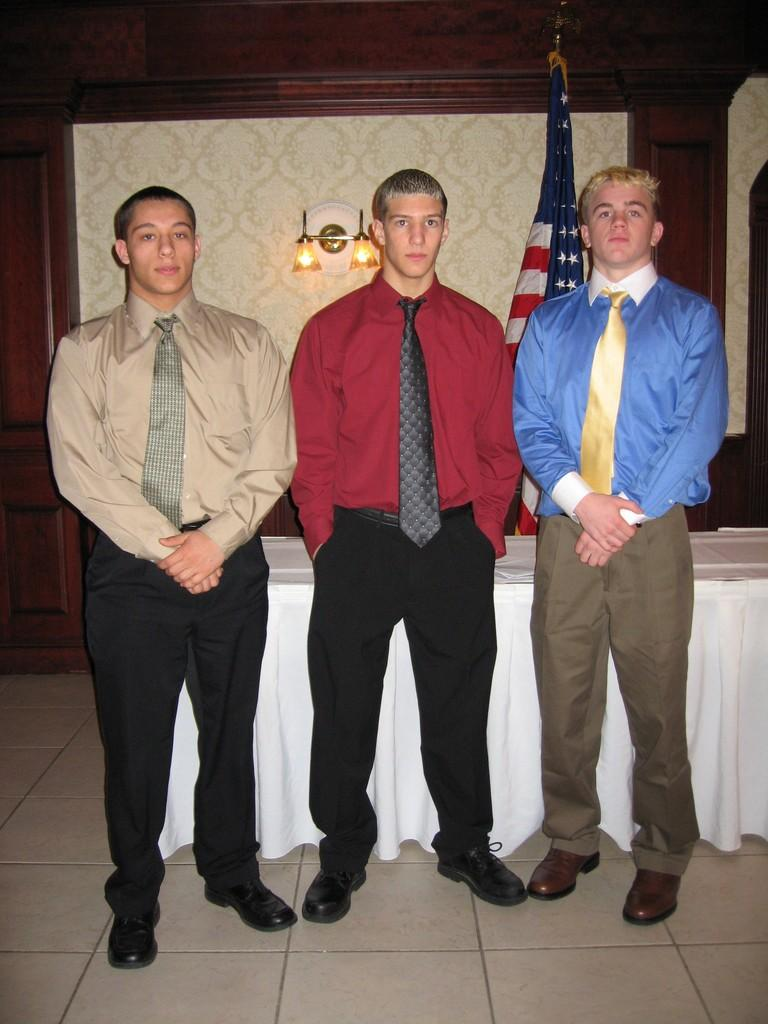What can be seen in the image regarding people? There are persons standing in the image. What is visible beneath the persons' feet? The floor is visible in the image. What is present on the table in the image? There is a table covered with cloth in the image. What is the symbolic object in the image? There is a flag in the image. What type of lighting is present in the image? Electric lights are attached to the walls in the image. What type of texture can be seen on the rod in the image? There is no rod present in the image, so it is not possible to determine the texture. 